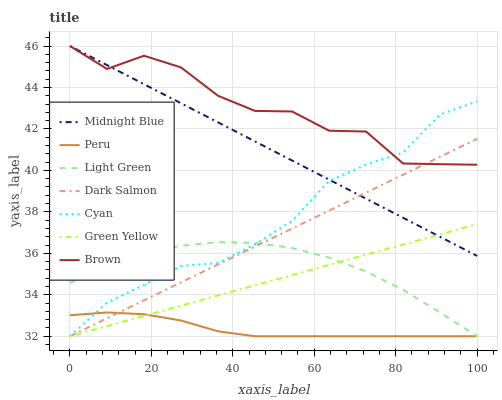Does Peru have the minimum area under the curve?
Answer yes or no. Yes. Does Brown have the maximum area under the curve?
Answer yes or no. Yes. Does Midnight Blue have the minimum area under the curve?
Answer yes or no. No. Does Midnight Blue have the maximum area under the curve?
Answer yes or no. No. Is Green Yellow the smoothest?
Answer yes or no. Yes. Is Brown the roughest?
Answer yes or no. Yes. Is Midnight Blue the smoothest?
Answer yes or no. No. Is Midnight Blue the roughest?
Answer yes or no. No. Does Dark Salmon have the lowest value?
Answer yes or no. Yes. Does Midnight Blue have the lowest value?
Answer yes or no. No. Does Midnight Blue have the highest value?
Answer yes or no. Yes. Does Dark Salmon have the highest value?
Answer yes or no. No. Is Green Yellow less than Brown?
Answer yes or no. Yes. Is Brown greater than Light Green?
Answer yes or no. Yes. Does Brown intersect Cyan?
Answer yes or no. Yes. Is Brown less than Cyan?
Answer yes or no. No. Is Brown greater than Cyan?
Answer yes or no. No. Does Green Yellow intersect Brown?
Answer yes or no. No. 